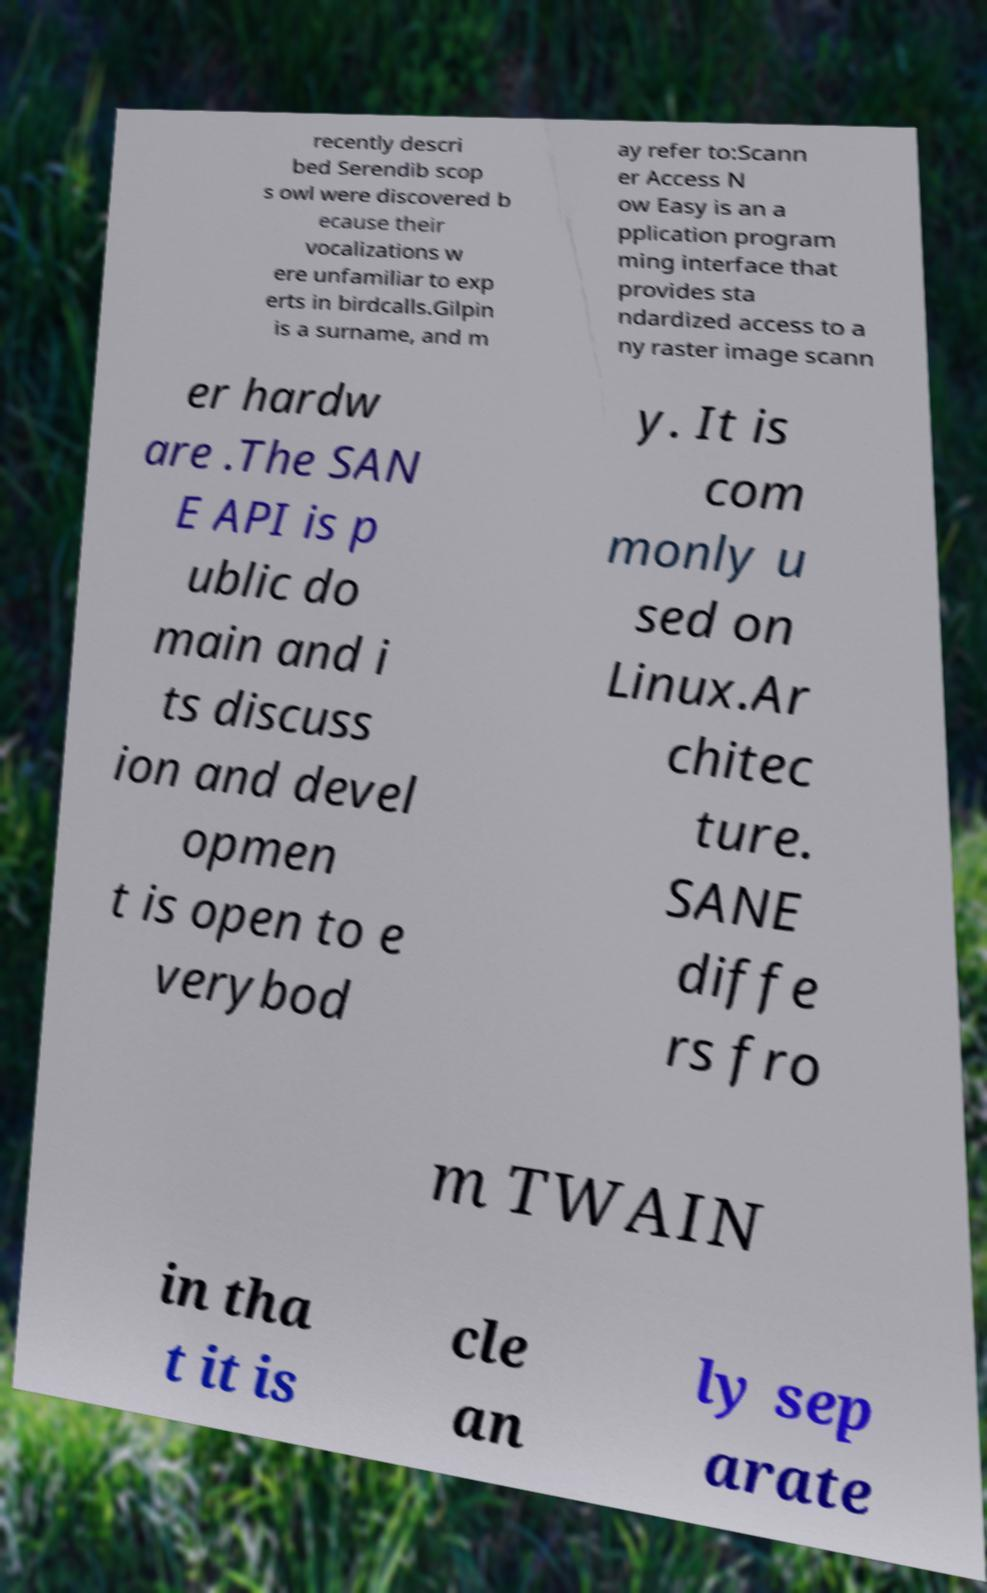Could you extract and type out the text from this image? recently descri bed Serendib scop s owl were discovered b ecause their vocalizations w ere unfamiliar to exp erts in birdcalls.Gilpin is a surname, and m ay refer to:Scann er Access N ow Easy is an a pplication program ming interface that provides sta ndardized access to a ny raster image scann er hardw are .The SAN E API is p ublic do main and i ts discuss ion and devel opmen t is open to e verybod y. It is com monly u sed on Linux.Ar chitec ture. SANE diffe rs fro m TWAIN in tha t it is cle an ly sep arate 